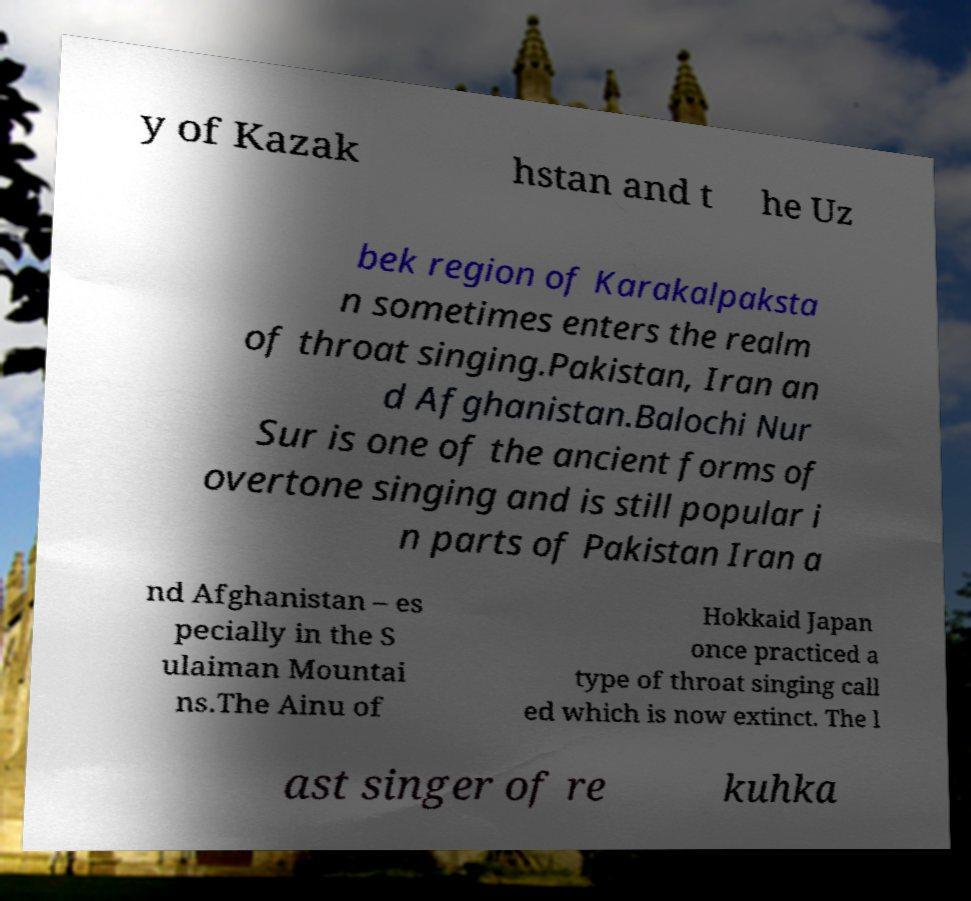Please read and relay the text visible in this image. What does it say? y of Kazak hstan and t he Uz bek region of Karakalpaksta n sometimes enters the realm of throat singing.Pakistan, Iran an d Afghanistan.Balochi Nur Sur is one of the ancient forms of overtone singing and is still popular i n parts of Pakistan Iran a nd Afghanistan – es pecially in the S ulaiman Mountai ns.The Ainu of Hokkaid Japan once practiced a type of throat singing call ed which is now extinct. The l ast singer of re kuhka 